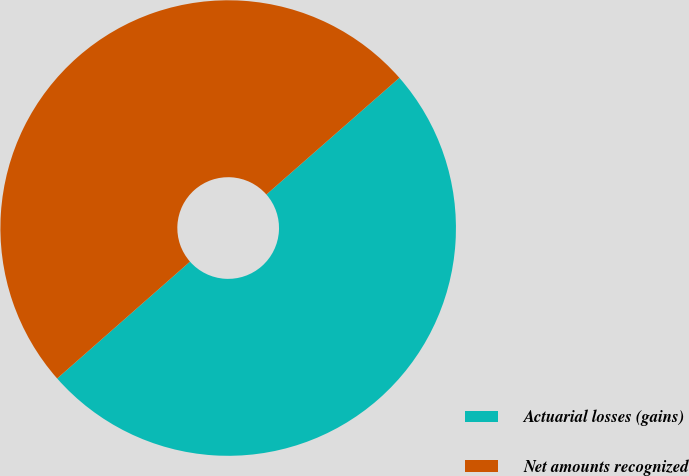<chart> <loc_0><loc_0><loc_500><loc_500><pie_chart><fcel>Actuarial losses (gains)<fcel>Net amounts recognized<nl><fcel>49.98%<fcel>50.02%<nl></chart> 